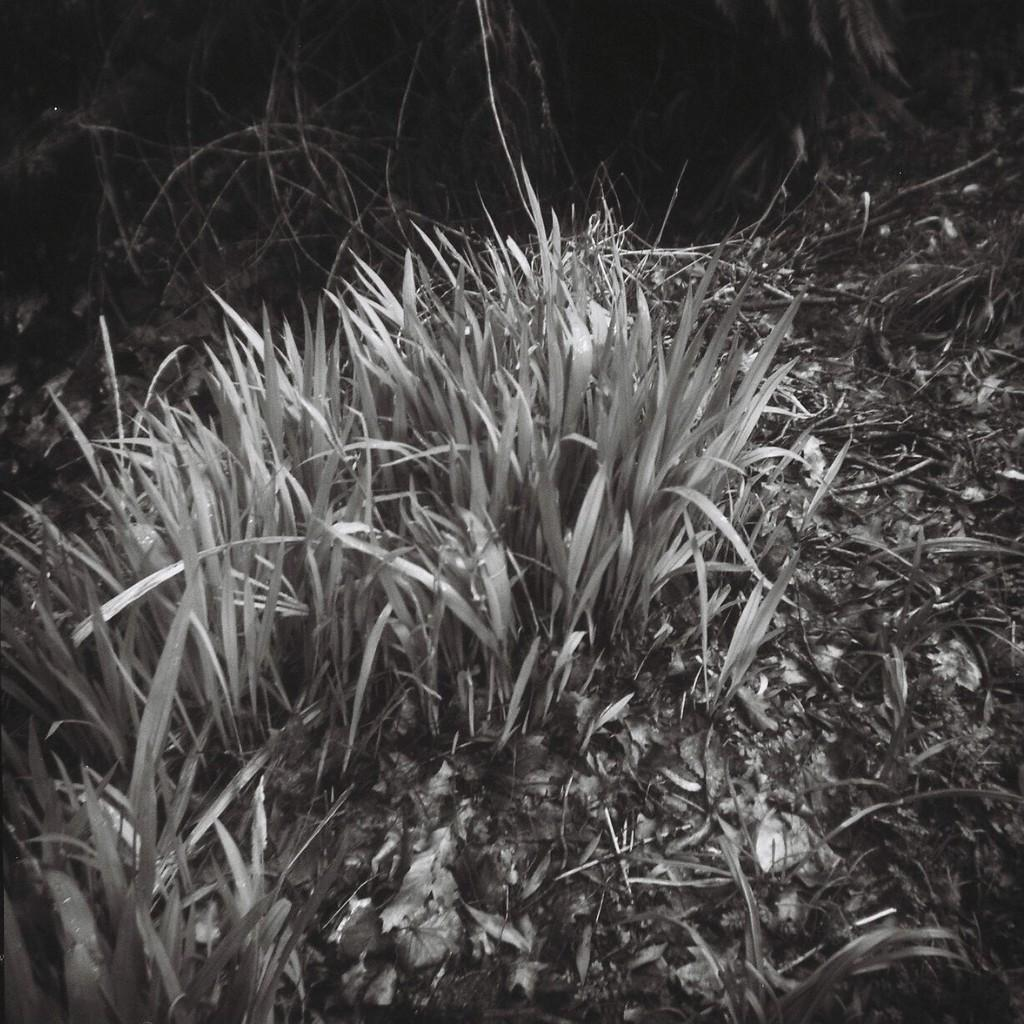What type of living organisms can be seen in the image? Plants can be seen in the image. Can you tell me how many bees are present in the image? There is no bee present in the image; it only features plants. What religion do the plants in the image follow? Plants do not follow any religion, as they are living organisms and not capable of religious beliefs or practices. 